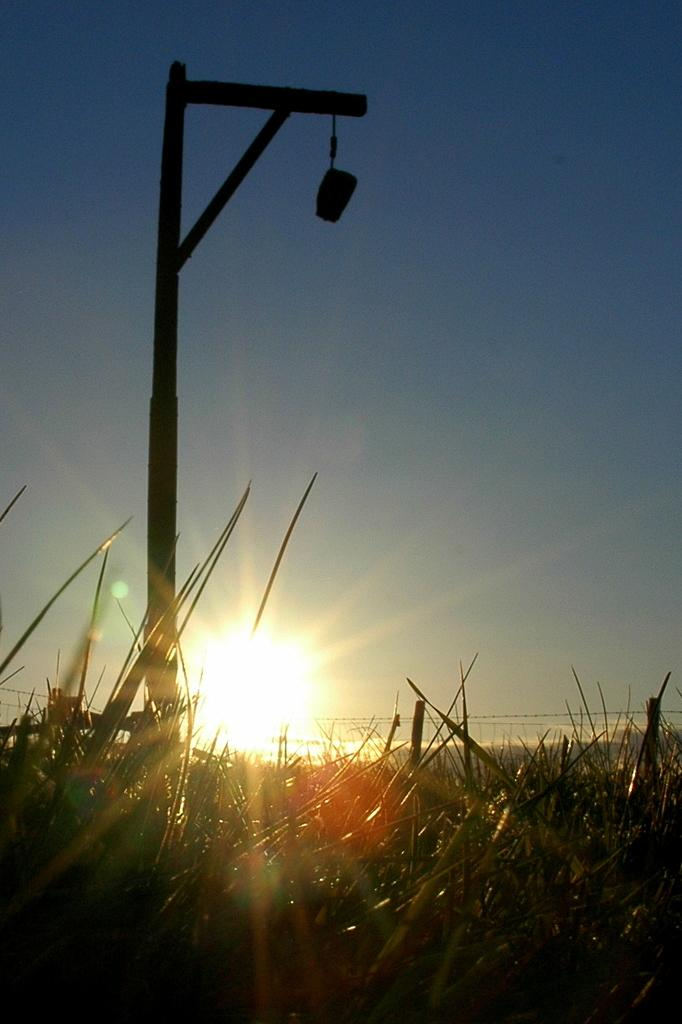What is the main object in the image? There is a pole in the image. What type of surface is visible at the bottom of the image? Grass is visible at the bottom of the image. What can be seen in the background of the image? The sky is visible in the background of the image. What is hanging from the pole? There is an object hanging from the pole. How many legs does the calculator have in the image? There is no calculator present in the image, so it is not possible to determine the number of legs it might have. 